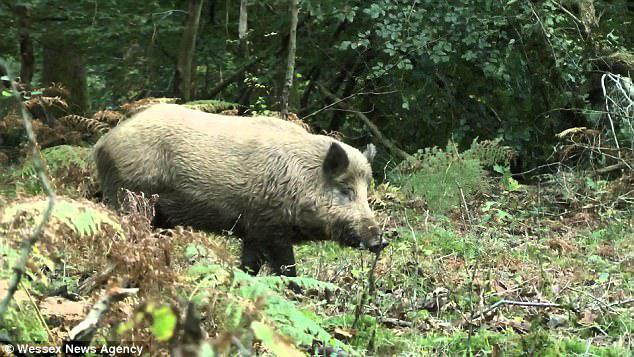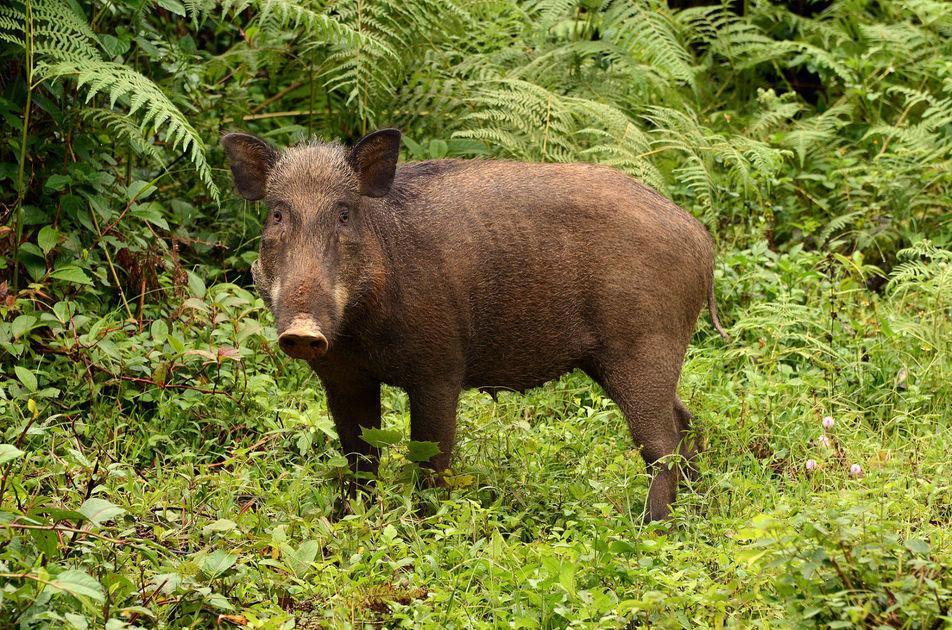The first image is the image on the left, the second image is the image on the right. Evaluate the accuracy of this statement regarding the images: "There are exactly two pigs.". Is it true? Answer yes or no. Yes. 